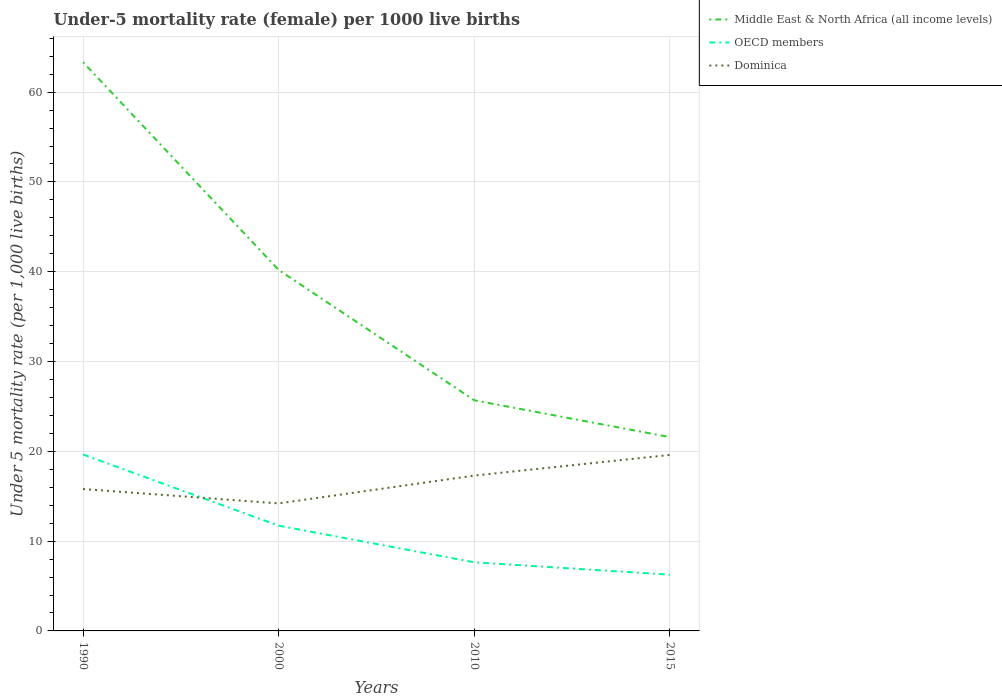How many different coloured lines are there?
Your answer should be compact. 3. Does the line corresponding to OECD members intersect with the line corresponding to Middle East & North Africa (all income levels)?
Provide a short and direct response. No. Is the number of lines equal to the number of legend labels?
Your answer should be compact. Yes. Across all years, what is the maximum under-five mortality rate in Dominica?
Make the answer very short. 14.2. What is the total under-five mortality rate in OECD members in the graph?
Your answer should be compact. 13.38. What is the difference between the highest and the second highest under-five mortality rate in Middle East & North Africa (all income levels)?
Provide a succinct answer. 41.75. What is the difference between the highest and the lowest under-five mortality rate in OECD members?
Ensure brevity in your answer.  2. Is the under-five mortality rate in Middle East & North Africa (all income levels) strictly greater than the under-five mortality rate in OECD members over the years?
Give a very brief answer. No. What is the difference between two consecutive major ticks on the Y-axis?
Give a very brief answer. 10. Are the values on the major ticks of Y-axis written in scientific E-notation?
Ensure brevity in your answer.  No. Does the graph contain any zero values?
Provide a short and direct response. No. Does the graph contain grids?
Offer a terse response. Yes. What is the title of the graph?
Your answer should be compact. Under-5 mortality rate (female) per 1000 live births. What is the label or title of the Y-axis?
Your response must be concise. Under 5 mortality rate (per 1,0 live births). What is the Under 5 mortality rate (per 1,000 live births) of Middle East & North Africa (all income levels) in 1990?
Ensure brevity in your answer.  63.33. What is the Under 5 mortality rate (per 1,000 live births) of OECD members in 1990?
Provide a short and direct response. 19.64. What is the Under 5 mortality rate (per 1,000 live births) of Dominica in 1990?
Your answer should be very brief. 15.8. What is the Under 5 mortality rate (per 1,000 live births) in Middle East & North Africa (all income levels) in 2000?
Offer a very short reply. 40.2. What is the Under 5 mortality rate (per 1,000 live births) in OECD members in 2000?
Give a very brief answer. 11.72. What is the Under 5 mortality rate (per 1,000 live births) of Dominica in 2000?
Make the answer very short. 14.2. What is the Under 5 mortality rate (per 1,000 live births) in Middle East & North Africa (all income levels) in 2010?
Give a very brief answer. 25.68. What is the Under 5 mortality rate (per 1,000 live births) of OECD members in 2010?
Provide a succinct answer. 7.64. What is the Under 5 mortality rate (per 1,000 live births) of Middle East & North Africa (all income levels) in 2015?
Offer a terse response. 21.58. What is the Under 5 mortality rate (per 1,000 live births) of OECD members in 2015?
Your answer should be very brief. 6.26. What is the Under 5 mortality rate (per 1,000 live births) in Dominica in 2015?
Your answer should be compact. 19.6. Across all years, what is the maximum Under 5 mortality rate (per 1,000 live births) of Middle East & North Africa (all income levels)?
Provide a short and direct response. 63.33. Across all years, what is the maximum Under 5 mortality rate (per 1,000 live births) in OECD members?
Provide a short and direct response. 19.64. Across all years, what is the maximum Under 5 mortality rate (per 1,000 live births) of Dominica?
Ensure brevity in your answer.  19.6. Across all years, what is the minimum Under 5 mortality rate (per 1,000 live births) of Middle East & North Africa (all income levels)?
Your response must be concise. 21.58. Across all years, what is the minimum Under 5 mortality rate (per 1,000 live births) of OECD members?
Offer a terse response. 6.26. What is the total Under 5 mortality rate (per 1,000 live births) of Middle East & North Africa (all income levels) in the graph?
Offer a very short reply. 150.79. What is the total Under 5 mortality rate (per 1,000 live births) of OECD members in the graph?
Offer a very short reply. 45.26. What is the total Under 5 mortality rate (per 1,000 live births) in Dominica in the graph?
Offer a very short reply. 66.9. What is the difference between the Under 5 mortality rate (per 1,000 live births) of Middle East & North Africa (all income levels) in 1990 and that in 2000?
Provide a short and direct response. 23.14. What is the difference between the Under 5 mortality rate (per 1,000 live births) in OECD members in 1990 and that in 2000?
Provide a short and direct response. 7.92. What is the difference between the Under 5 mortality rate (per 1,000 live births) in Middle East & North Africa (all income levels) in 1990 and that in 2010?
Provide a succinct answer. 37.65. What is the difference between the Under 5 mortality rate (per 1,000 live births) of OECD members in 1990 and that in 2010?
Provide a succinct answer. 12.01. What is the difference between the Under 5 mortality rate (per 1,000 live births) of Dominica in 1990 and that in 2010?
Ensure brevity in your answer.  -1.5. What is the difference between the Under 5 mortality rate (per 1,000 live births) in Middle East & North Africa (all income levels) in 1990 and that in 2015?
Ensure brevity in your answer.  41.75. What is the difference between the Under 5 mortality rate (per 1,000 live births) of OECD members in 1990 and that in 2015?
Keep it short and to the point. 13.38. What is the difference between the Under 5 mortality rate (per 1,000 live births) in Dominica in 1990 and that in 2015?
Your response must be concise. -3.8. What is the difference between the Under 5 mortality rate (per 1,000 live births) of Middle East & North Africa (all income levels) in 2000 and that in 2010?
Keep it short and to the point. 14.51. What is the difference between the Under 5 mortality rate (per 1,000 live births) of OECD members in 2000 and that in 2010?
Offer a very short reply. 4.08. What is the difference between the Under 5 mortality rate (per 1,000 live births) of Middle East & North Africa (all income levels) in 2000 and that in 2015?
Give a very brief answer. 18.62. What is the difference between the Under 5 mortality rate (per 1,000 live births) in OECD members in 2000 and that in 2015?
Your response must be concise. 5.46. What is the difference between the Under 5 mortality rate (per 1,000 live births) in Dominica in 2000 and that in 2015?
Make the answer very short. -5.4. What is the difference between the Under 5 mortality rate (per 1,000 live births) of Middle East & North Africa (all income levels) in 2010 and that in 2015?
Your response must be concise. 4.1. What is the difference between the Under 5 mortality rate (per 1,000 live births) of OECD members in 2010 and that in 2015?
Provide a short and direct response. 1.38. What is the difference between the Under 5 mortality rate (per 1,000 live births) of Middle East & North Africa (all income levels) in 1990 and the Under 5 mortality rate (per 1,000 live births) of OECD members in 2000?
Provide a succinct answer. 51.61. What is the difference between the Under 5 mortality rate (per 1,000 live births) in Middle East & North Africa (all income levels) in 1990 and the Under 5 mortality rate (per 1,000 live births) in Dominica in 2000?
Keep it short and to the point. 49.13. What is the difference between the Under 5 mortality rate (per 1,000 live births) in OECD members in 1990 and the Under 5 mortality rate (per 1,000 live births) in Dominica in 2000?
Your answer should be compact. 5.44. What is the difference between the Under 5 mortality rate (per 1,000 live births) of Middle East & North Africa (all income levels) in 1990 and the Under 5 mortality rate (per 1,000 live births) of OECD members in 2010?
Give a very brief answer. 55.69. What is the difference between the Under 5 mortality rate (per 1,000 live births) in Middle East & North Africa (all income levels) in 1990 and the Under 5 mortality rate (per 1,000 live births) in Dominica in 2010?
Your response must be concise. 46.03. What is the difference between the Under 5 mortality rate (per 1,000 live births) in OECD members in 1990 and the Under 5 mortality rate (per 1,000 live births) in Dominica in 2010?
Offer a terse response. 2.34. What is the difference between the Under 5 mortality rate (per 1,000 live births) in Middle East & North Africa (all income levels) in 1990 and the Under 5 mortality rate (per 1,000 live births) in OECD members in 2015?
Your answer should be very brief. 57.07. What is the difference between the Under 5 mortality rate (per 1,000 live births) of Middle East & North Africa (all income levels) in 1990 and the Under 5 mortality rate (per 1,000 live births) of Dominica in 2015?
Provide a succinct answer. 43.73. What is the difference between the Under 5 mortality rate (per 1,000 live births) of OECD members in 1990 and the Under 5 mortality rate (per 1,000 live births) of Dominica in 2015?
Keep it short and to the point. 0.04. What is the difference between the Under 5 mortality rate (per 1,000 live births) of Middle East & North Africa (all income levels) in 2000 and the Under 5 mortality rate (per 1,000 live births) of OECD members in 2010?
Give a very brief answer. 32.56. What is the difference between the Under 5 mortality rate (per 1,000 live births) in Middle East & North Africa (all income levels) in 2000 and the Under 5 mortality rate (per 1,000 live births) in Dominica in 2010?
Your answer should be very brief. 22.9. What is the difference between the Under 5 mortality rate (per 1,000 live births) of OECD members in 2000 and the Under 5 mortality rate (per 1,000 live births) of Dominica in 2010?
Your response must be concise. -5.58. What is the difference between the Under 5 mortality rate (per 1,000 live births) of Middle East & North Africa (all income levels) in 2000 and the Under 5 mortality rate (per 1,000 live births) of OECD members in 2015?
Offer a very short reply. 33.94. What is the difference between the Under 5 mortality rate (per 1,000 live births) in Middle East & North Africa (all income levels) in 2000 and the Under 5 mortality rate (per 1,000 live births) in Dominica in 2015?
Your answer should be compact. 20.6. What is the difference between the Under 5 mortality rate (per 1,000 live births) in OECD members in 2000 and the Under 5 mortality rate (per 1,000 live births) in Dominica in 2015?
Keep it short and to the point. -7.88. What is the difference between the Under 5 mortality rate (per 1,000 live births) in Middle East & North Africa (all income levels) in 2010 and the Under 5 mortality rate (per 1,000 live births) in OECD members in 2015?
Keep it short and to the point. 19.42. What is the difference between the Under 5 mortality rate (per 1,000 live births) of Middle East & North Africa (all income levels) in 2010 and the Under 5 mortality rate (per 1,000 live births) of Dominica in 2015?
Your response must be concise. 6.08. What is the difference between the Under 5 mortality rate (per 1,000 live births) in OECD members in 2010 and the Under 5 mortality rate (per 1,000 live births) in Dominica in 2015?
Ensure brevity in your answer.  -11.96. What is the average Under 5 mortality rate (per 1,000 live births) of Middle East & North Africa (all income levels) per year?
Your answer should be very brief. 37.7. What is the average Under 5 mortality rate (per 1,000 live births) in OECD members per year?
Your answer should be very brief. 11.32. What is the average Under 5 mortality rate (per 1,000 live births) in Dominica per year?
Your answer should be very brief. 16.73. In the year 1990, what is the difference between the Under 5 mortality rate (per 1,000 live births) in Middle East & North Africa (all income levels) and Under 5 mortality rate (per 1,000 live births) in OECD members?
Offer a terse response. 43.69. In the year 1990, what is the difference between the Under 5 mortality rate (per 1,000 live births) of Middle East & North Africa (all income levels) and Under 5 mortality rate (per 1,000 live births) of Dominica?
Offer a terse response. 47.53. In the year 1990, what is the difference between the Under 5 mortality rate (per 1,000 live births) in OECD members and Under 5 mortality rate (per 1,000 live births) in Dominica?
Make the answer very short. 3.84. In the year 2000, what is the difference between the Under 5 mortality rate (per 1,000 live births) of Middle East & North Africa (all income levels) and Under 5 mortality rate (per 1,000 live births) of OECD members?
Ensure brevity in your answer.  28.48. In the year 2000, what is the difference between the Under 5 mortality rate (per 1,000 live births) in Middle East & North Africa (all income levels) and Under 5 mortality rate (per 1,000 live births) in Dominica?
Provide a succinct answer. 26. In the year 2000, what is the difference between the Under 5 mortality rate (per 1,000 live births) of OECD members and Under 5 mortality rate (per 1,000 live births) of Dominica?
Give a very brief answer. -2.48. In the year 2010, what is the difference between the Under 5 mortality rate (per 1,000 live births) in Middle East & North Africa (all income levels) and Under 5 mortality rate (per 1,000 live births) in OECD members?
Keep it short and to the point. 18.04. In the year 2010, what is the difference between the Under 5 mortality rate (per 1,000 live births) in Middle East & North Africa (all income levels) and Under 5 mortality rate (per 1,000 live births) in Dominica?
Offer a terse response. 8.38. In the year 2010, what is the difference between the Under 5 mortality rate (per 1,000 live births) of OECD members and Under 5 mortality rate (per 1,000 live births) of Dominica?
Offer a very short reply. -9.66. In the year 2015, what is the difference between the Under 5 mortality rate (per 1,000 live births) in Middle East & North Africa (all income levels) and Under 5 mortality rate (per 1,000 live births) in OECD members?
Keep it short and to the point. 15.32. In the year 2015, what is the difference between the Under 5 mortality rate (per 1,000 live births) in Middle East & North Africa (all income levels) and Under 5 mortality rate (per 1,000 live births) in Dominica?
Offer a terse response. 1.98. In the year 2015, what is the difference between the Under 5 mortality rate (per 1,000 live births) in OECD members and Under 5 mortality rate (per 1,000 live births) in Dominica?
Your answer should be compact. -13.34. What is the ratio of the Under 5 mortality rate (per 1,000 live births) in Middle East & North Africa (all income levels) in 1990 to that in 2000?
Ensure brevity in your answer.  1.58. What is the ratio of the Under 5 mortality rate (per 1,000 live births) in OECD members in 1990 to that in 2000?
Offer a terse response. 1.68. What is the ratio of the Under 5 mortality rate (per 1,000 live births) of Dominica in 1990 to that in 2000?
Your answer should be compact. 1.11. What is the ratio of the Under 5 mortality rate (per 1,000 live births) in Middle East & North Africa (all income levels) in 1990 to that in 2010?
Make the answer very short. 2.47. What is the ratio of the Under 5 mortality rate (per 1,000 live births) in OECD members in 1990 to that in 2010?
Give a very brief answer. 2.57. What is the ratio of the Under 5 mortality rate (per 1,000 live births) of Dominica in 1990 to that in 2010?
Provide a succinct answer. 0.91. What is the ratio of the Under 5 mortality rate (per 1,000 live births) of Middle East & North Africa (all income levels) in 1990 to that in 2015?
Offer a terse response. 2.93. What is the ratio of the Under 5 mortality rate (per 1,000 live births) of OECD members in 1990 to that in 2015?
Provide a short and direct response. 3.14. What is the ratio of the Under 5 mortality rate (per 1,000 live births) in Dominica in 1990 to that in 2015?
Your response must be concise. 0.81. What is the ratio of the Under 5 mortality rate (per 1,000 live births) of Middle East & North Africa (all income levels) in 2000 to that in 2010?
Keep it short and to the point. 1.57. What is the ratio of the Under 5 mortality rate (per 1,000 live births) in OECD members in 2000 to that in 2010?
Provide a succinct answer. 1.53. What is the ratio of the Under 5 mortality rate (per 1,000 live births) in Dominica in 2000 to that in 2010?
Offer a very short reply. 0.82. What is the ratio of the Under 5 mortality rate (per 1,000 live births) in Middle East & North Africa (all income levels) in 2000 to that in 2015?
Give a very brief answer. 1.86. What is the ratio of the Under 5 mortality rate (per 1,000 live births) in OECD members in 2000 to that in 2015?
Offer a terse response. 1.87. What is the ratio of the Under 5 mortality rate (per 1,000 live births) in Dominica in 2000 to that in 2015?
Ensure brevity in your answer.  0.72. What is the ratio of the Under 5 mortality rate (per 1,000 live births) of Middle East & North Africa (all income levels) in 2010 to that in 2015?
Ensure brevity in your answer.  1.19. What is the ratio of the Under 5 mortality rate (per 1,000 live births) of OECD members in 2010 to that in 2015?
Ensure brevity in your answer.  1.22. What is the ratio of the Under 5 mortality rate (per 1,000 live births) in Dominica in 2010 to that in 2015?
Your answer should be very brief. 0.88. What is the difference between the highest and the second highest Under 5 mortality rate (per 1,000 live births) of Middle East & North Africa (all income levels)?
Offer a very short reply. 23.14. What is the difference between the highest and the second highest Under 5 mortality rate (per 1,000 live births) of OECD members?
Offer a terse response. 7.92. What is the difference between the highest and the lowest Under 5 mortality rate (per 1,000 live births) of Middle East & North Africa (all income levels)?
Give a very brief answer. 41.75. What is the difference between the highest and the lowest Under 5 mortality rate (per 1,000 live births) in OECD members?
Ensure brevity in your answer.  13.38. 